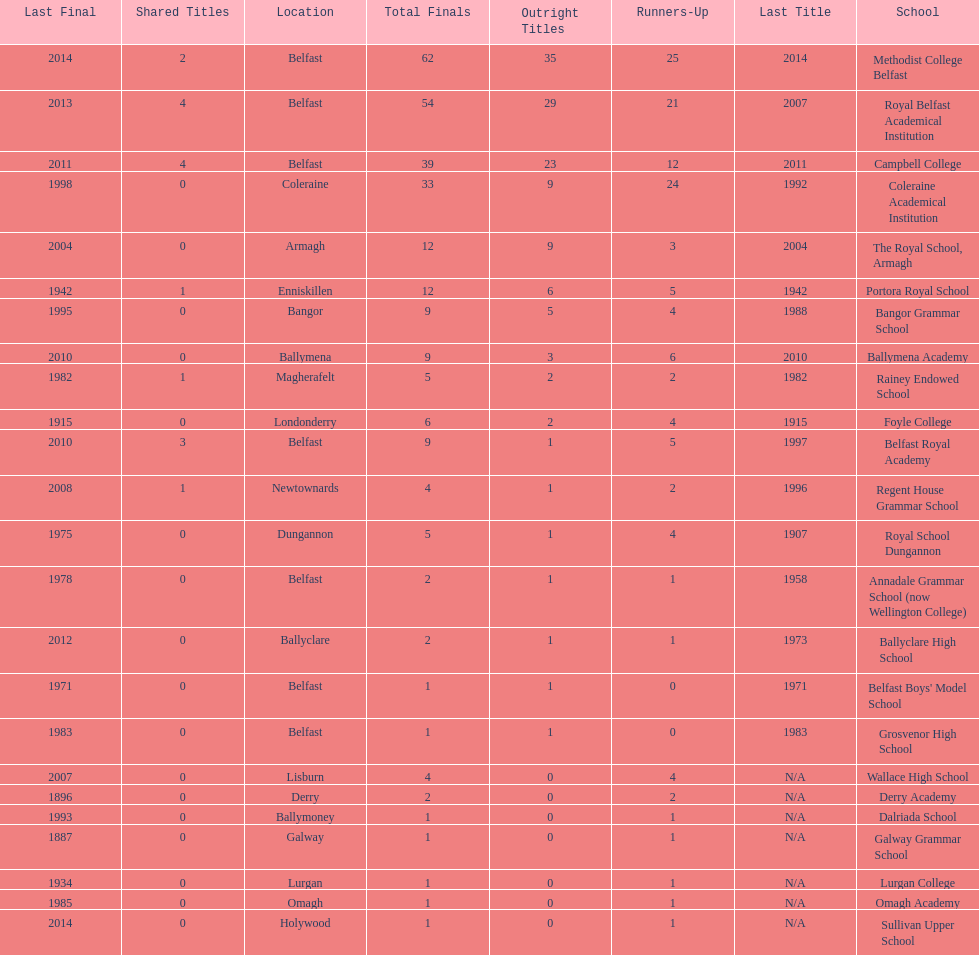Did belfast royal academy have more or less total finals than ballyclare high school? More. 